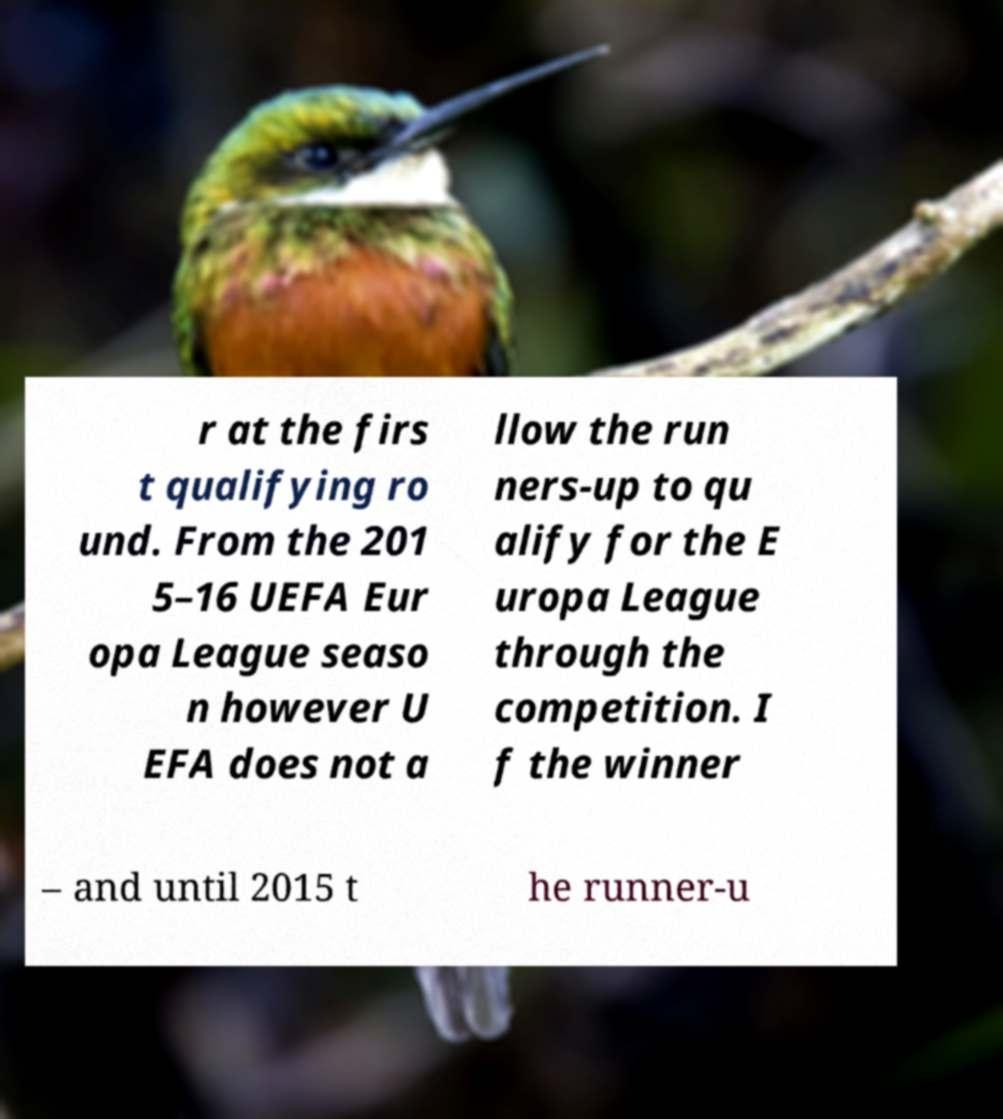Can you read and provide the text displayed in the image?This photo seems to have some interesting text. Can you extract and type it out for me? r at the firs t qualifying ro und. From the 201 5–16 UEFA Eur opa League seaso n however U EFA does not a llow the run ners-up to qu alify for the E uropa League through the competition. I f the winner – and until 2015 t he runner-u 